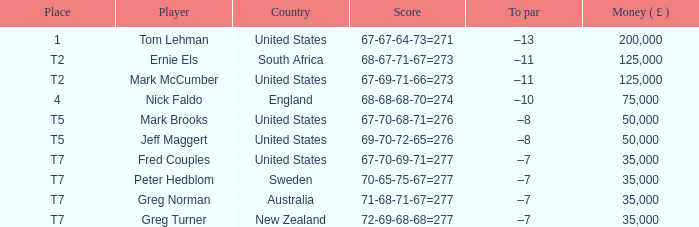I'm looking to parse the entire table for insights. Could you assist me with that? {'header': ['Place', 'Player', 'Country', 'Score', 'To par', 'Money ( £ )'], 'rows': [['1', 'Tom Lehman', 'United States', '67-67-64-73=271', '–13', '200,000'], ['T2', 'Ernie Els', 'South Africa', '68-67-71-67=273', '–11', '125,000'], ['T2', 'Mark McCumber', 'United States', '67-69-71-66=273', '–11', '125,000'], ['4', 'Nick Faldo', 'England', '68-68-68-70=274', '–10', '75,000'], ['T5', 'Mark Brooks', 'United States', '67-70-68-71=276', '–8', '50,000'], ['T5', 'Jeff Maggert', 'United States', '69-70-72-65=276', '–8', '50,000'], ['T7', 'Fred Couples', 'United States', '67-70-69-71=277', '–7', '35,000'], ['T7', 'Peter Hedblom', 'Sweden', '70-65-75-67=277', '–7', '35,000'], ['T7', 'Greg Norman', 'Australia', '71-68-71-67=277', '–7', '35,000'], ['T7', 'Greg Turner', 'New Zealand', '72-69-68-68=277', '–7', '35,000']]} What is Score, when Money ( £ ) is greater than 35,000, and when Country is "United States"? 67-67-64-73=271, 67-69-71-66=273, 67-70-68-71=276, 69-70-72-65=276. 